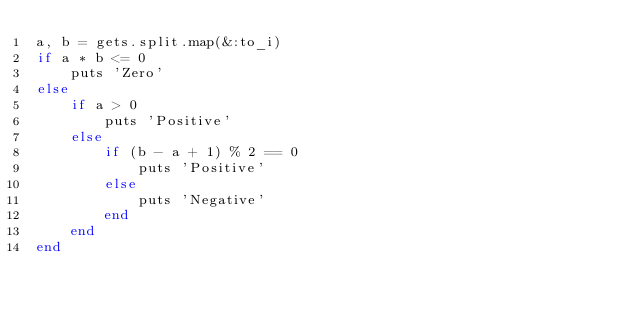Convert code to text. <code><loc_0><loc_0><loc_500><loc_500><_Ruby_>a, b = gets.split.map(&:to_i)
if a * b <= 0
    puts 'Zero' 
else
    if a > 0
        puts 'Positive'
    else
        if (b - a + 1) % 2 == 0
            puts 'Positive'
        else
            puts 'Negative' 
        end
    end
end</code> 